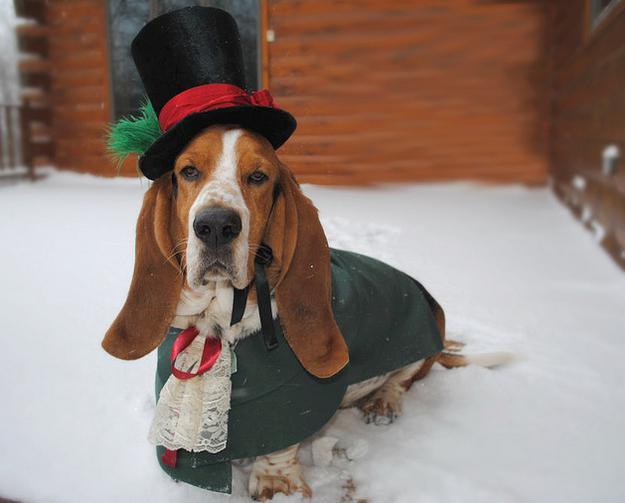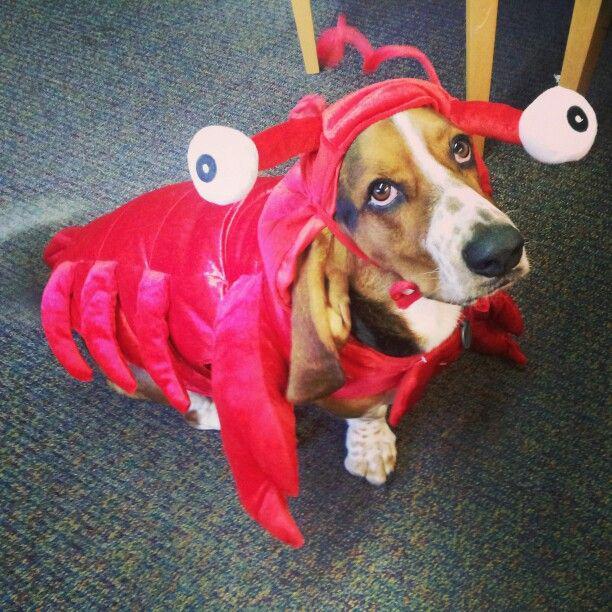The first image is the image on the left, the second image is the image on the right. Evaluate the accuracy of this statement regarding the images: "a dog is wearing a costume". Is it true? Answer yes or no. Yes. 